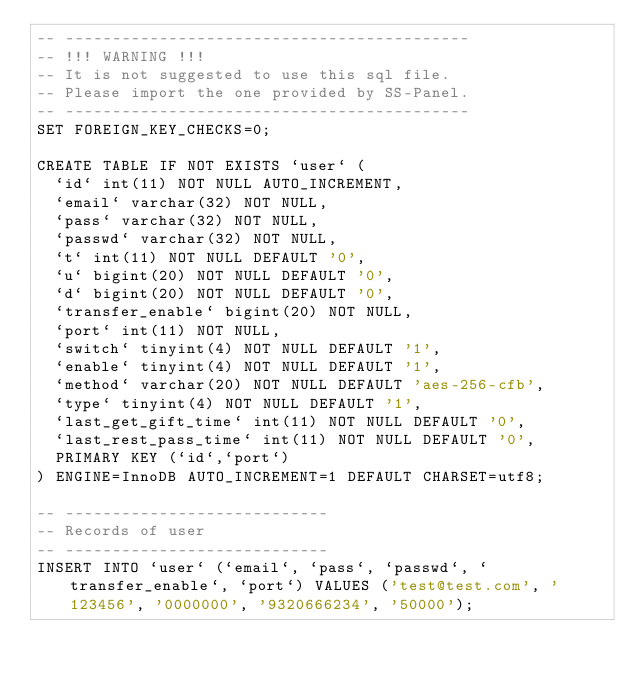Convert code to text. <code><loc_0><loc_0><loc_500><loc_500><_SQL_>-- -------------------------------------------
-- !!! WARNING !!!
-- It is not suggested to use this sql file.
-- Please import the one provided by SS-Panel.
-- -------------------------------------------
SET FOREIGN_KEY_CHECKS=0;

CREATE TABLE IF NOT EXISTS `user` (
  `id` int(11) NOT NULL AUTO_INCREMENT,
  `email` varchar(32) NOT NULL,
  `pass` varchar(32) NOT NULL,
  `passwd` varchar(32) NOT NULL,
  `t` int(11) NOT NULL DEFAULT '0',
  `u` bigint(20) NOT NULL DEFAULT '0',
  `d` bigint(20) NOT NULL DEFAULT '0',
  `transfer_enable` bigint(20) NOT NULL,
  `port` int(11) NOT NULL,
  `switch` tinyint(4) NOT NULL DEFAULT '1',
  `enable` tinyint(4) NOT NULL DEFAULT '1',
  `method` varchar(20) NOT NULL DEFAULT 'aes-256-cfb',
  `type` tinyint(4) NOT NULL DEFAULT '1',
  `last_get_gift_time` int(11) NOT NULL DEFAULT '0',
  `last_rest_pass_time` int(11) NOT NULL DEFAULT '0',
  PRIMARY KEY (`id`,`port`)
) ENGINE=InnoDB AUTO_INCREMENT=1 DEFAULT CHARSET=utf8;

-- ----------------------------
-- Records of user
-- ----------------------------
INSERT INTO `user` (`email`, `pass`, `passwd`, `transfer_enable`, `port`) VALUES ('test@test.com', '123456', '0000000', '9320666234', '50000');
</code> 